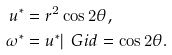<formula> <loc_0><loc_0><loc_500><loc_500>u ^ { * } & = r ^ { 2 } \cos 2 \theta , \\ \omega ^ { * } & = u ^ { * } | _ { \ } G i d = \cos 2 \theta .</formula> 